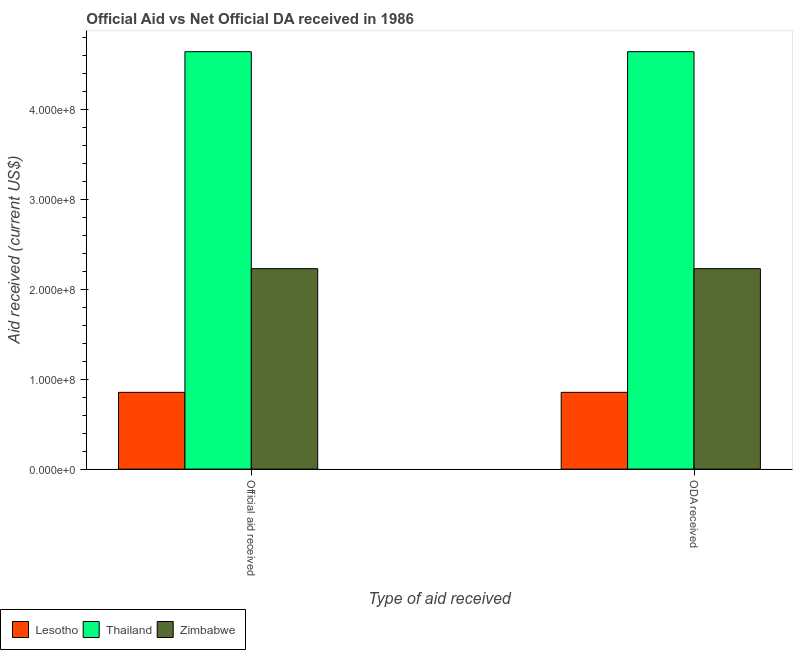How many groups of bars are there?
Offer a terse response. 2. How many bars are there on the 2nd tick from the left?
Make the answer very short. 3. What is the label of the 1st group of bars from the left?
Your response must be concise. Official aid received. What is the official aid received in Lesotho?
Give a very brief answer. 8.54e+07. Across all countries, what is the maximum official aid received?
Give a very brief answer. 4.64e+08. Across all countries, what is the minimum official aid received?
Offer a very short reply. 8.54e+07. In which country was the official aid received maximum?
Give a very brief answer. Thailand. In which country was the official aid received minimum?
Provide a short and direct response. Lesotho. What is the total official aid received in the graph?
Provide a short and direct response. 7.73e+08. What is the difference between the official aid received in Zimbabwe and that in Lesotho?
Offer a very short reply. 1.38e+08. What is the difference between the oda received in Lesotho and the official aid received in Zimbabwe?
Offer a terse response. -1.38e+08. What is the average oda received per country?
Give a very brief answer. 2.58e+08. In how many countries, is the oda received greater than 300000000 US$?
Provide a short and direct response. 1. What is the ratio of the official aid received in Thailand to that in Zimbabwe?
Offer a very short reply. 2.08. Is the oda received in Zimbabwe less than that in Lesotho?
Give a very brief answer. No. What does the 3rd bar from the left in ODA received represents?
Ensure brevity in your answer.  Zimbabwe. What does the 2nd bar from the right in Official aid received represents?
Offer a terse response. Thailand. How many bars are there?
Provide a short and direct response. 6. Are all the bars in the graph horizontal?
Your response must be concise. No. How many countries are there in the graph?
Provide a succinct answer. 3. Does the graph contain any zero values?
Make the answer very short. No. Where does the legend appear in the graph?
Offer a terse response. Bottom left. What is the title of the graph?
Your answer should be very brief. Official Aid vs Net Official DA received in 1986 . What is the label or title of the X-axis?
Provide a short and direct response. Type of aid received. What is the label or title of the Y-axis?
Your answer should be compact. Aid received (current US$). What is the Aid received (current US$) in Lesotho in Official aid received?
Provide a succinct answer. 8.54e+07. What is the Aid received (current US$) of Thailand in Official aid received?
Provide a succinct answer. 4.64e+08. What is the Aid received (current US$) of Zimbabwe in Official aid received?
Make the answer very short. 2.23e+08. What is the Aid received (current US$) in Lesotho in ODA received?
Your answer should be very brief. 8.54e+07. What is the Aid received (current US$) in Thailand in ODA received?
Keep it short and to the point. 4.64e+08. What is the Aid received (current US$) of Zimbabwe in ODA received?
Make the answer very short. 2.23e+08. Across all Type of aid received, what is the maximum Aid received (current US$) in Lesotho?
Offer a very short reply. 8.54e+07. Across all Type of aid received, what is the maximum Aid received (current US$) of Thailand?
Keep it short and to the point. 4.64e+08. Across all Type of aid received, what is the maximum Aid received (current US$) of Zimbabwe?
Offer a very short reply. 2.23e+08. Across all Type of aid received, what is the minimum Aid received (current US$) of Lesotho?
Provide a succinct answer. 8.54e+07. Across all Type of aid received, what is the minimum Aid received (current US$) of Thailand?
Your response must be concise. 4.64e+08. Across all Type of aid received, what is the minimum Aid received (current US$) of Zimbabwe?
Offer a very short reply. 2.23e+08. What is the total Aid received (current US$) of Lesotho in the graph?
Give a very brief answer. 1.71e+08. What is the total Aid received (current US$) in Thailand in the graph?
Provide a short and direct response. 9.29e+08. What is the total Aid received (current US$) of Zimbabwe in the graph?
Your response must be concise. 4.46e+08. What is the difference between the Aid received (current US$) of Lesotho in Official aid received and that in ODA received?
Your response must be concise. 0. What is the difference between the Aid received (current US$) of Thailand in Official aid received and that in ODA received?
Provide a short and direct response. 0. What is the difference between the Aid received (current US$) of Zimbabwe in Official aid received and that in ODA received?
Offer a very short reply. 0. What is the difference between the Aid received (current US$) of Lesotho in Official aid received and the Aid received (current US$) of Thailand in ODA received?
Give a very brief answer. -3.79e+08. What is the difference between the Aid received (current US$) of Lesotho in Official aid received and the Aid received (current US$) of Zimbabwe in ODA received?
Provide a succinct answer. -1.38e+08. What is the difference between the Aid received (current US$) in Thailand in Official aid received and the Aid received (current US$) in Zimbabwe in ODA received?
Give a very brief answer. 2.41e+08. What is the average Aid received (current US$) in Lesotho per Type of aid received?
Your response must be concise. 8.54e+07. What is the average Aid received (current US$) of Thailand per Type of aid received?
Your answer should be very brief. 4.64e+08. What is the average Aid received (current US$) in Zimbabwe per Type of aid received?
Your answer should be compact. 2.23e+08. What is the difference between the Aid received (current US$) in Lesotho and Aid received (current US$) in Thailand in Official aid received?
Your answer should be compact. -3.79e+08. What is the difference between the Aid received (current US$) in Lesotho and Aid received (current US$) in Zimbabwe in Official aid received?
Offer a very short reply. -1.38e+08. What is the difference between the Aid received (current US$) of Thailand and Aid received (current US$) of Zimbabwe in Official aid received?
Provide a succinct answer. 2.41e+08. What is the difference between the Aid received (current US$) of Lesotho and Aid received (current US$) of Thailand in ODA received?
Provide a succinct answer. -3.79e+08. What is the difference between the Aid received (current US$) in Lesotho and Aid received (current US$) in Zimbabwe in ODA received?
Ensure brevity in your answer.  -1.38e+08. What is the difference between the Aid received (current US$) in Thailand and Aid received (current US$) in Zimbabwe in ODA received?
Offer a terse response. 2.41e+08. What is the ratio of the Aid received (current US$) in Thailand in Official aid received to that in ODA received?
Provide a short and direct response. 1. What is the difference between the highest and the second highest Aid received (current US$) of Thailand?
Ensure brevity in your answer.  0. What is the difference between the highest and the second highest Aid received (current US$) of Zimbabwe?
Your answer should be compact. 0. What is the difference between the highest and the lowest Aid received (current US$) in Zimbabwe?
Make the answer very short. 0. 